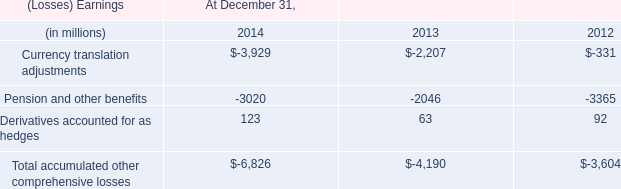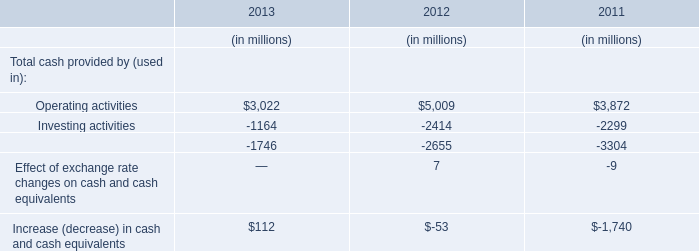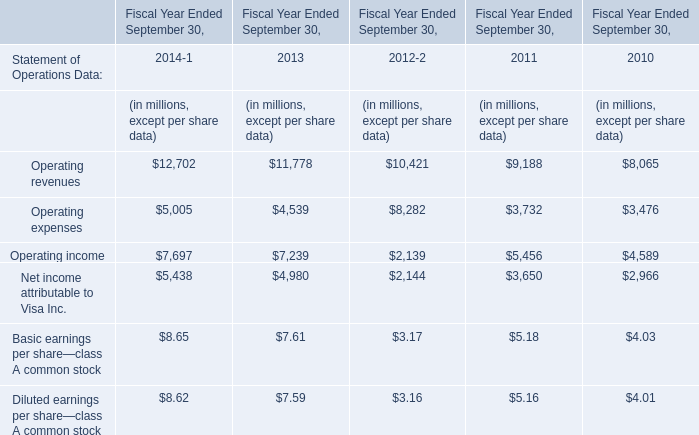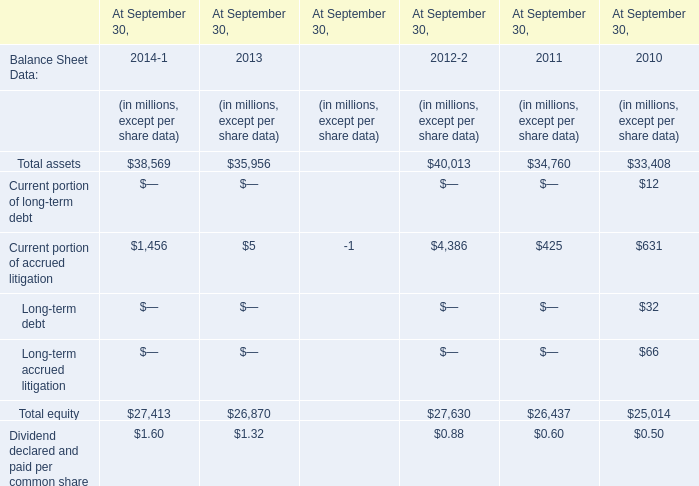As As the chart 2 shows,the Operating income in which Fiscal Year Ended September 30 ranks first? 
Answer: 2014. 